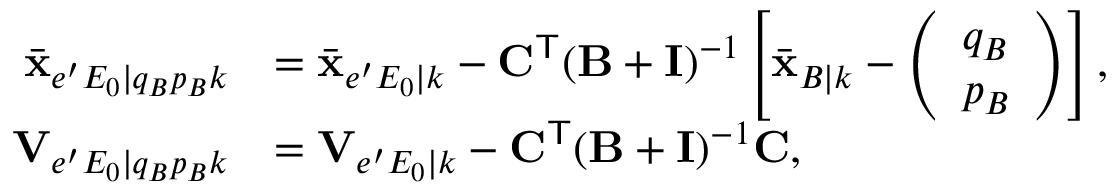<formula> <loc_0><loc_0><loc_500><loc_500>\begin{array} { r l } { \bar { x } _ { e ^ { \prime } E _ { 0 } | q _ { B } p _ { B } k } } & { = \bar { x } _ { e ^ { \prime } E _ { 0 } | k } - C ^ { T } ( B + I ) ^ { - 1 } \left [ \bar { x } _ { B | k } - \left ( \begin{array} { l } { q _ { B } } \\ { p _ { B } } \end{array} \right ) \right ] , } \\ { V _ { e ^ { \prime } E _ { 0 } | q _ { B } p _ { B } k } } & { = V _ { e ^ { \prime } E _ { 0 } | k } - C ^ { T } ( B + I ) ^ { - 1 } C , } \end{array}</formula> 